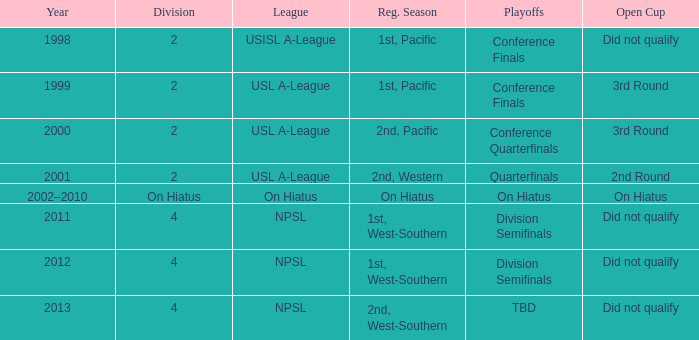Which playoffs took place during 2011? Division Semifinals. 